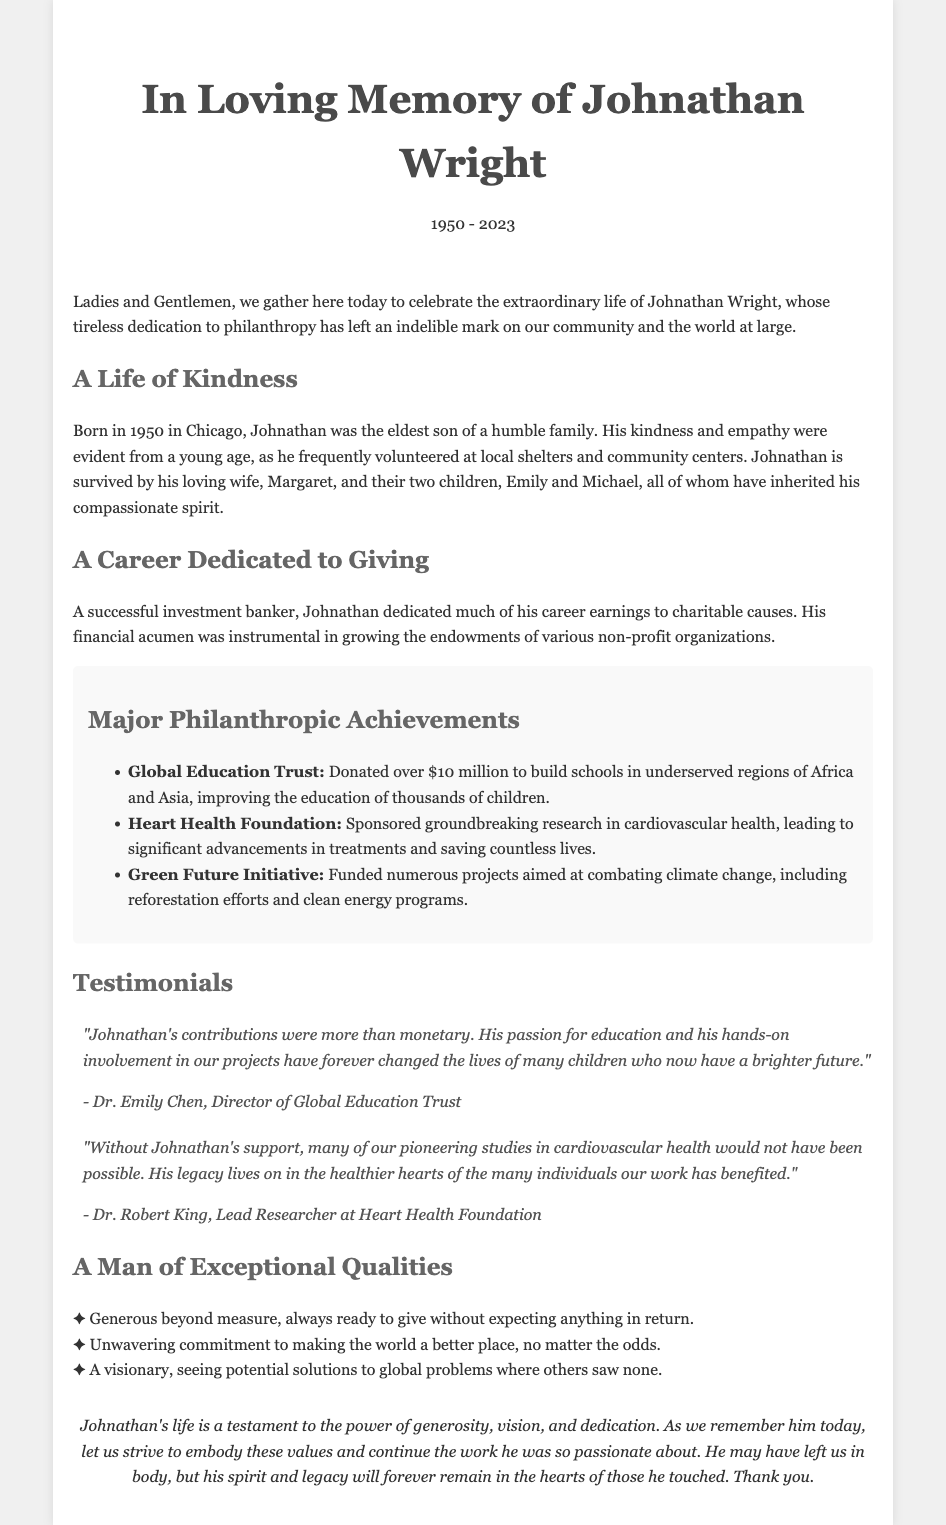What year was Johnathan Wright born? Johnathan Wright was born in 1950 according to the document.
Answer: 1950 What is the name of Johnathan's wife? The document states that Johnathan is survived by his loving wife, Margaret.
Answer: Margaret How many children did Johnathan have? The document mentions Johnathan has two children, Emily and Michael.
Answer: Two How much did Johnathan donate to the Global Education Trust? According to the document, he donated over $10 million to this trust.
Answer: Over $10 million Which foundation focused on cardiovascular health? The document mentions the Heart Health Foundation in relation to Johnathan's contributions.
Answer: Heart Health Foundation What was Johnathan's profession? The document describes him as a successful investment banker.
Answer: Investment banker What quality does the document emphasize about Johnathan's character? The document highlights his generosity as a prominent quality.
Answer: Generous Who is Dr. Emily Chen? Dr. Emily Chen is the Director of the Global Education Trust and has a testimonial about Johnathan.
Answer: Director of Global Education Trust What initiative did Johnathan support to address climate change? The document refers to the Green Future Initiative as one of the causes Johnathan supported.
Answer: Green Future Initiative 